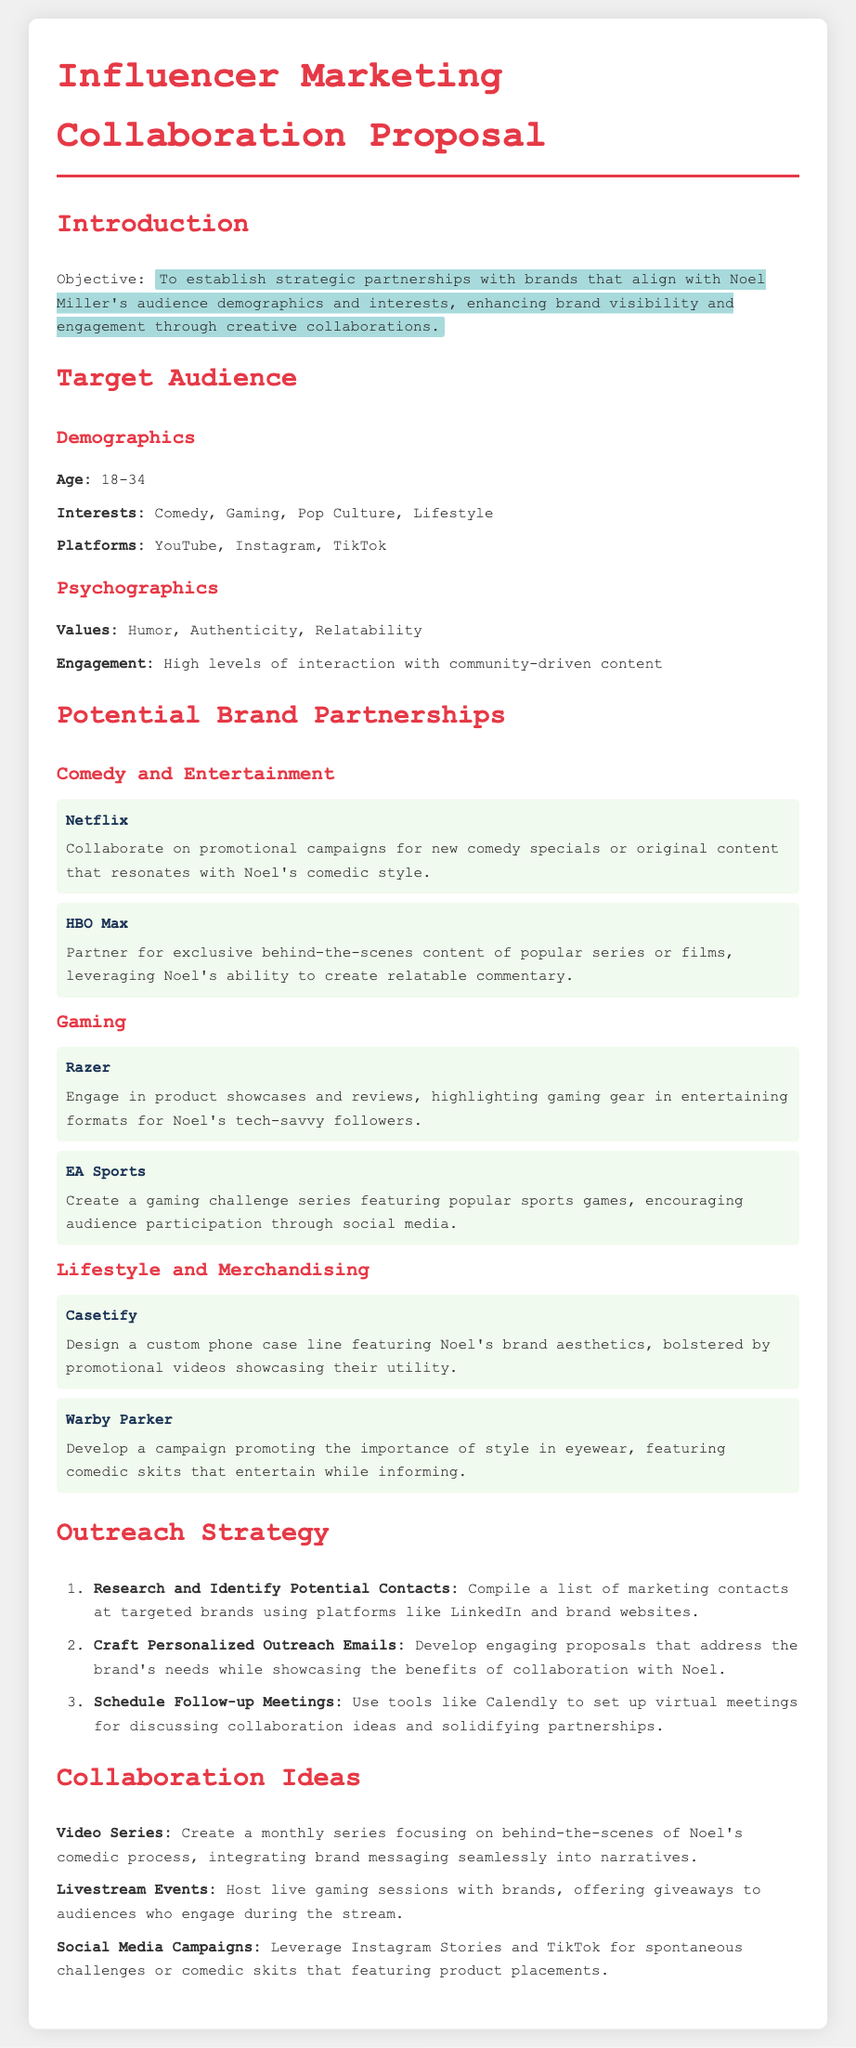what is the objective of the proposal? The objective is to establish strategic partnerships with brands that align with Noel Miller's audience demographics and interests.
Answer: To establish strategic partnerships what is the age range of the target audience? The age range specified in the document for the target audience is from 18 to 34 years old.
Answer: 18-34 which platform is mentioned for gaming-related partnerships? The document lists Razer and EA Sports as potential brand partnerships in the gaming section.
Answer: Razer, EA Sports name one value of the target audience's psychographics. The values identified in the document regarding the target audience's psychographics include humor, authenticity, and relatability.
Answer: Humor what type of content is suggested for collaboration with Netflix? The proposed collaboration with Netflix includes promotional campaigns for new comedy specials or original content.
Answer: Promotional campaigns how many steps are in the outreach strategy? The outreach strategy outlined in the proposal consists of three steps.
Answer: Three which brand is mentioned for custom phone case design? The brand mentioned for custom phone case design in the proposal is Casetify.
Answer: Casetify what is one collaboration idea involving social media? One collaboration idea suggested in the proposal is leveraging Instagram Stories and TikTok for spontaneous challenges.
Answer: Social media campaigns what is a recommended follow-up action after sending outreach emails? After sending outreach emails, the document recommends scheduling follow-up meetings to discuss collaboration ideas.
Answer: Schedule follow-up meetings 